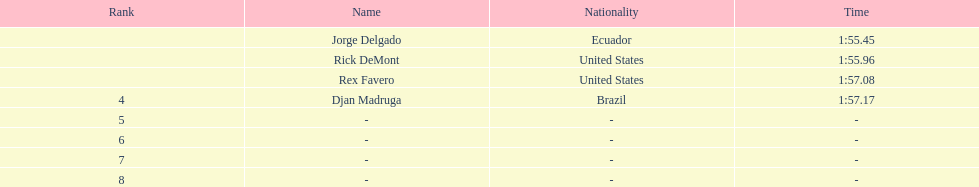What was the time immediately after favero completed in 1:5 1:57.17. 